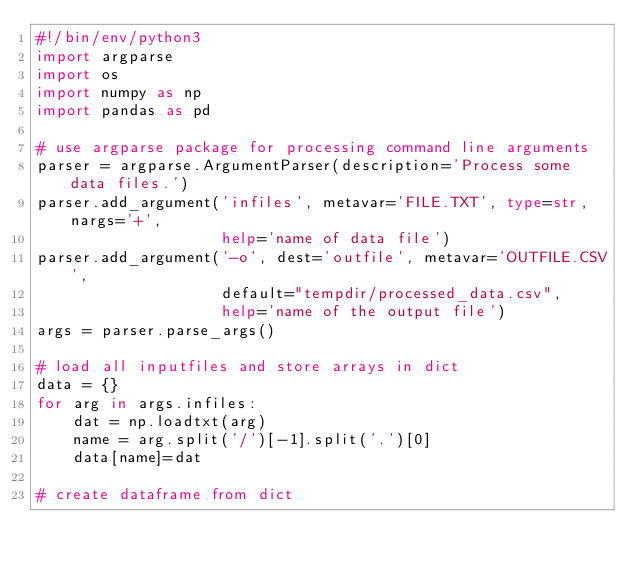<code> <loc_0><loc_0><loc_500><loc_500><_Python_>#!/bin/env/python3
import argparse
import os
import numpy as np
import pandas as pd

# use argparse package for processing command line arguments
parser = argparse.ArgumentParser(description='Process some data files.')
parser.add_argument('infiles', metavar='FILE.TXT', type=str, nargs='+',
                    help='name of data file')
parser.add_argument('-o', dest='outfile', metavar='OUTFILE.CSV',
                    default="tempdir/processed_data.csv",
                    help='name of the output file')
args = parser.parse_args()

# load all inputfiles and store arrays in dict
data = {}
for arg in args.infiles:
    dat = np.loadtxt(arg)
    name = arg.split('/')[-1].split('.')[0]
    data[name]=dat

# create dataframe from dict</code> 